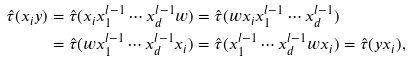<formula> <loc_0><loc_0><loc_500><loc_500>\hat { \tau } ( x _ { i } y ) & = \hat { \tau } ( x _ { i } x _ { 1 } ^ { l - 1 } \cdots x _ { d } ^ { l - 1 } w ) = \hat { \tau } ( w x _ { i } x _ { 1 } ^ { l - 1 } \cdots x _ { d } ^ { l - 1 } ) \\ & = \hat { \tau } ( w x _ { 1 } ^ { l - 1 } \cdots x _ { d } ^ { l - 1 } x _ { i } ) = \hat { \tau } ( x _ { 1 } ^ { l - 1 } \cdots x _ { d } ^ { l - 1 } w x _ { i } ) = \hat { \tau } ( y x _ { i } ) ,</formula> 